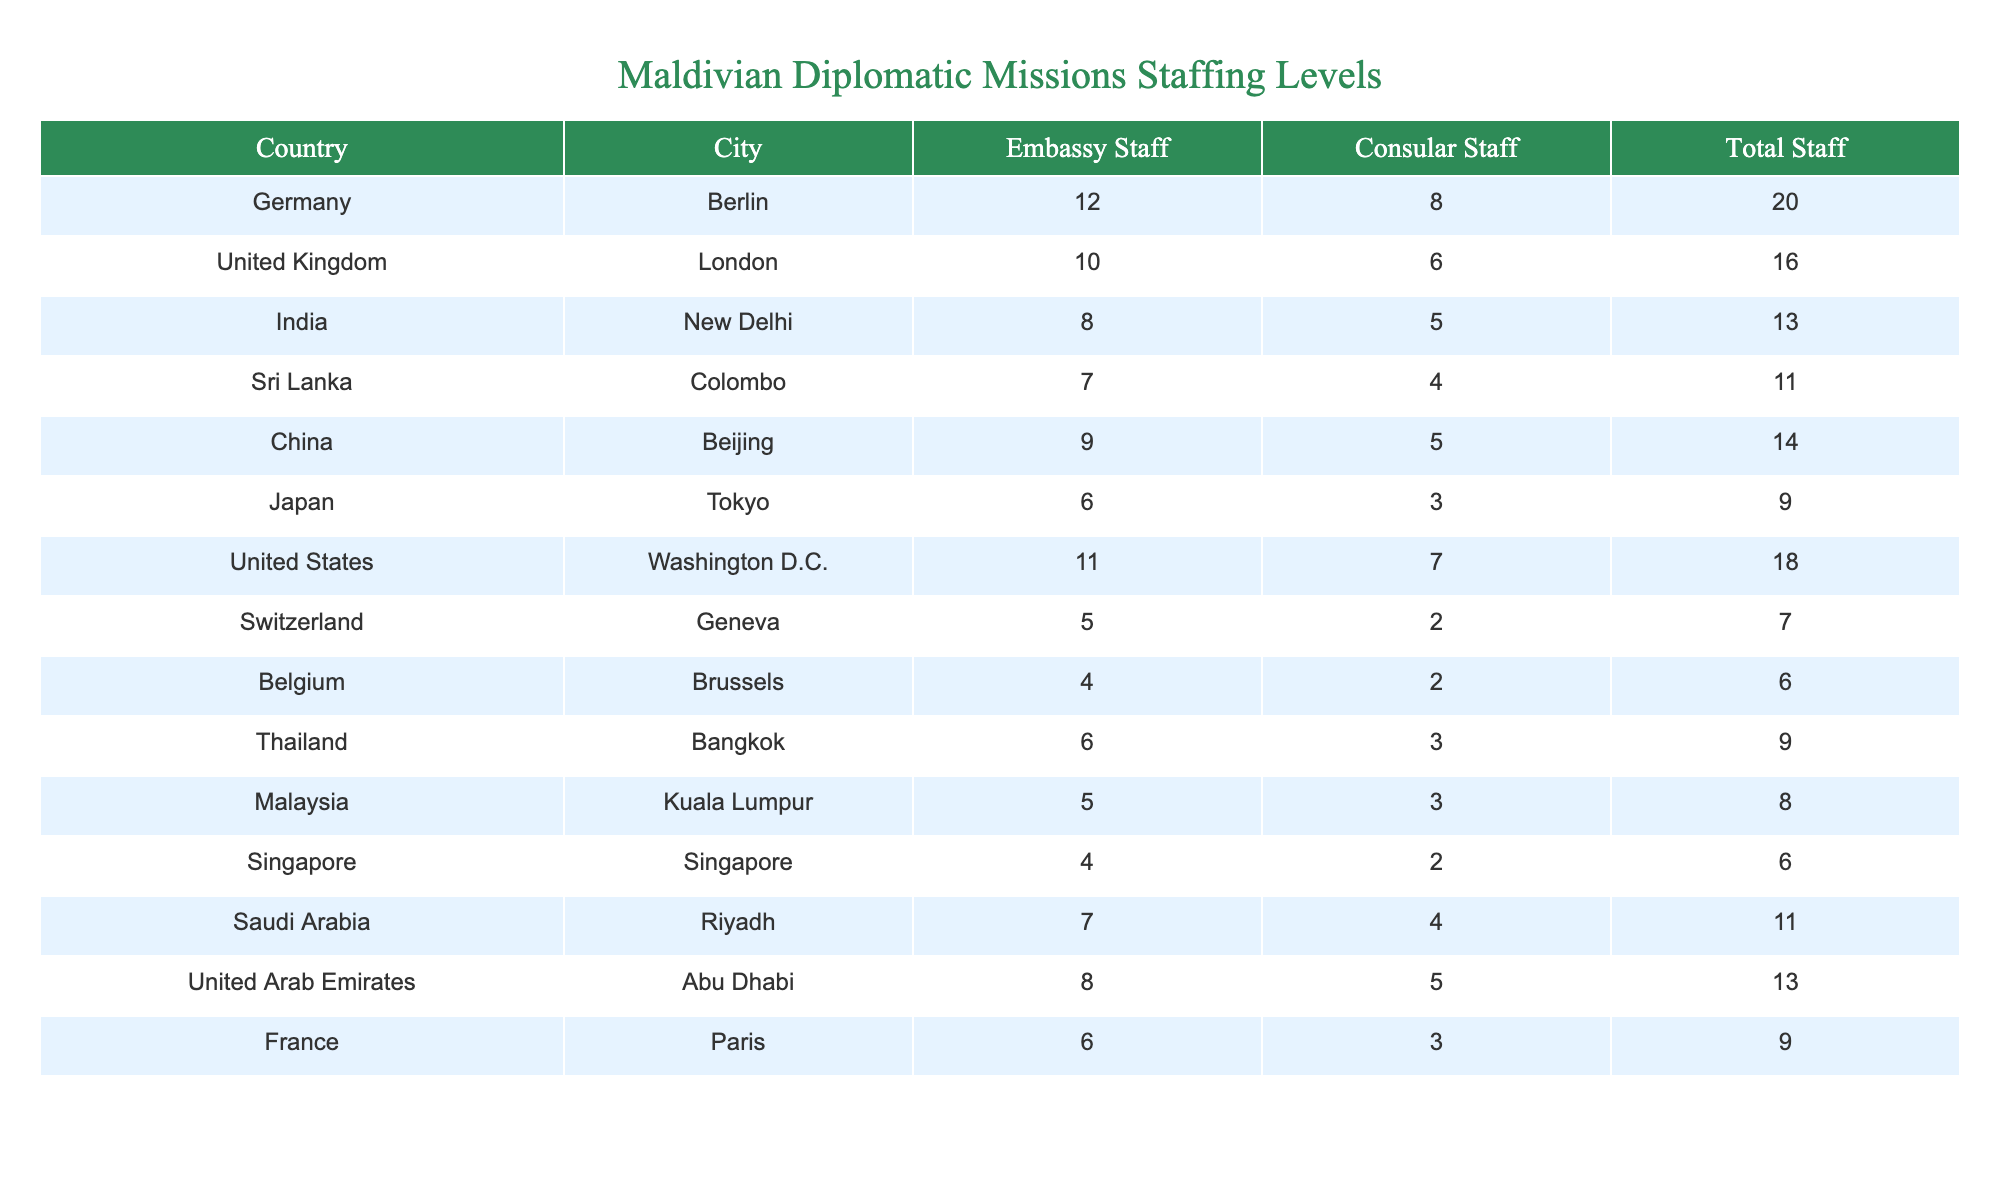What is the total number of embassy staff in Berlin? The table shows that the embassy staff in Berlin is 12.
Answer: 12 What is the combined total staff for the embassy and consulate in London? The total staff in London is the sum of embassy staff (10) and consular staff (6), which equals 16.
Answer: 16 Which country has the highest total staff level? The maximum total staff is found by comparing all totals; the United States has 18, which is the highest.
Answer: United States How many more total staff does the embassy in Washington D.C. have compared to the embassy in Berlin? Washington D.C. has 18 total staff and Berlin has 20 total staff. The difference is 20 - 18 = 2.
Answer: 2 What is the average number of embassy staff across all listed countries? The total number of embassy staff is calculated by summing: 12 + 10 + 8 + 7 + 9 + 6 + 11 + 5 + 4 + 6 + 5 + 4 + 7 + 8 + 6 = 16, and there are 15 countries, so the average is 16 / 15 = 6.67.
Answer: 6.67 Does Saudi Arabia have more consular staff than Japan? Saudi Arabia has 4 consular staff while Japan has 3. Therefore, yes, Saudi Arabia does have more.
Answer: Yes What is the total number of staff in the Swiss embassy? The table shows that Switzerland has a total of 7 staff members, which includes both embassy and consular staff.
Answer: 7 How many countries have a total staff of 11 or more? By counting the entries in the table, the countries with 11 or more total staff are: India, Sri Lanka, China, United States, Saudi Arabia, United Arab Emirates, resulting in 6 countries.
Answer: 6 Which country has the lowest total staff and what is that number? By checking the total staff numbers, Belgium and Singapore each have 6 as the lowest total.
Answer: 6 What is the difference in total staff between the embassy in New Delhi and the one in Beijing? New Delhi has 13 total staff, Beijing has 14. The difference is 14 - 13 = 1.
Answer: 1 Are there more embassy staff in Germany than in Malaysia? Germany has 12 embassy staff, while Malaysia has 5. Therefore, yes, there are more in Germany.
Answer: Yes 